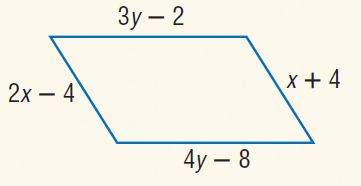Question: Find y so that the quadrilateral is a parallelogram.
Choices:
A. 2
B. 3
C. 6
D. 12
Answer with the letter. Answer: C Question: Find x so that the quadrilateral is a parallelogram.
Choices:
A. 4
B. 8
C. 16
D. 24
Answer with the letter. Answer: B 